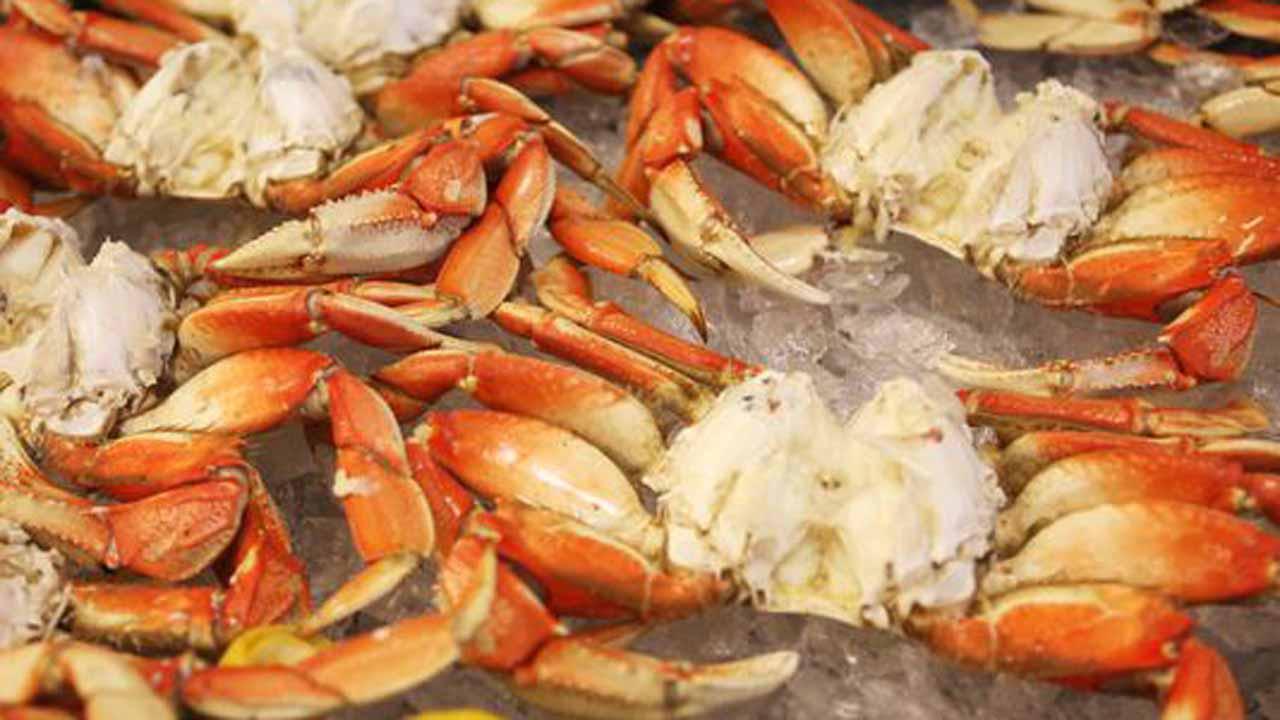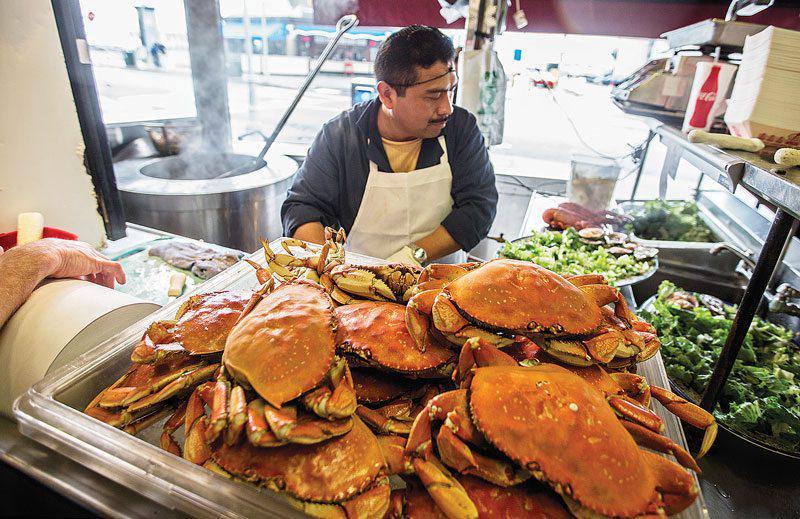The first image is the image on the left, the second image is the image on the right. Given the left and right images, does the statement "All images include at least one forward-facing reddish-orange crab with its shell intact." hold true? Answer yes or no. No. The first image is the image on the left, the second image is the image on the right. Analyze the images presented: Is the assertion "There is only one crab in at least one of the images." valid? Answer yes or no. No. 